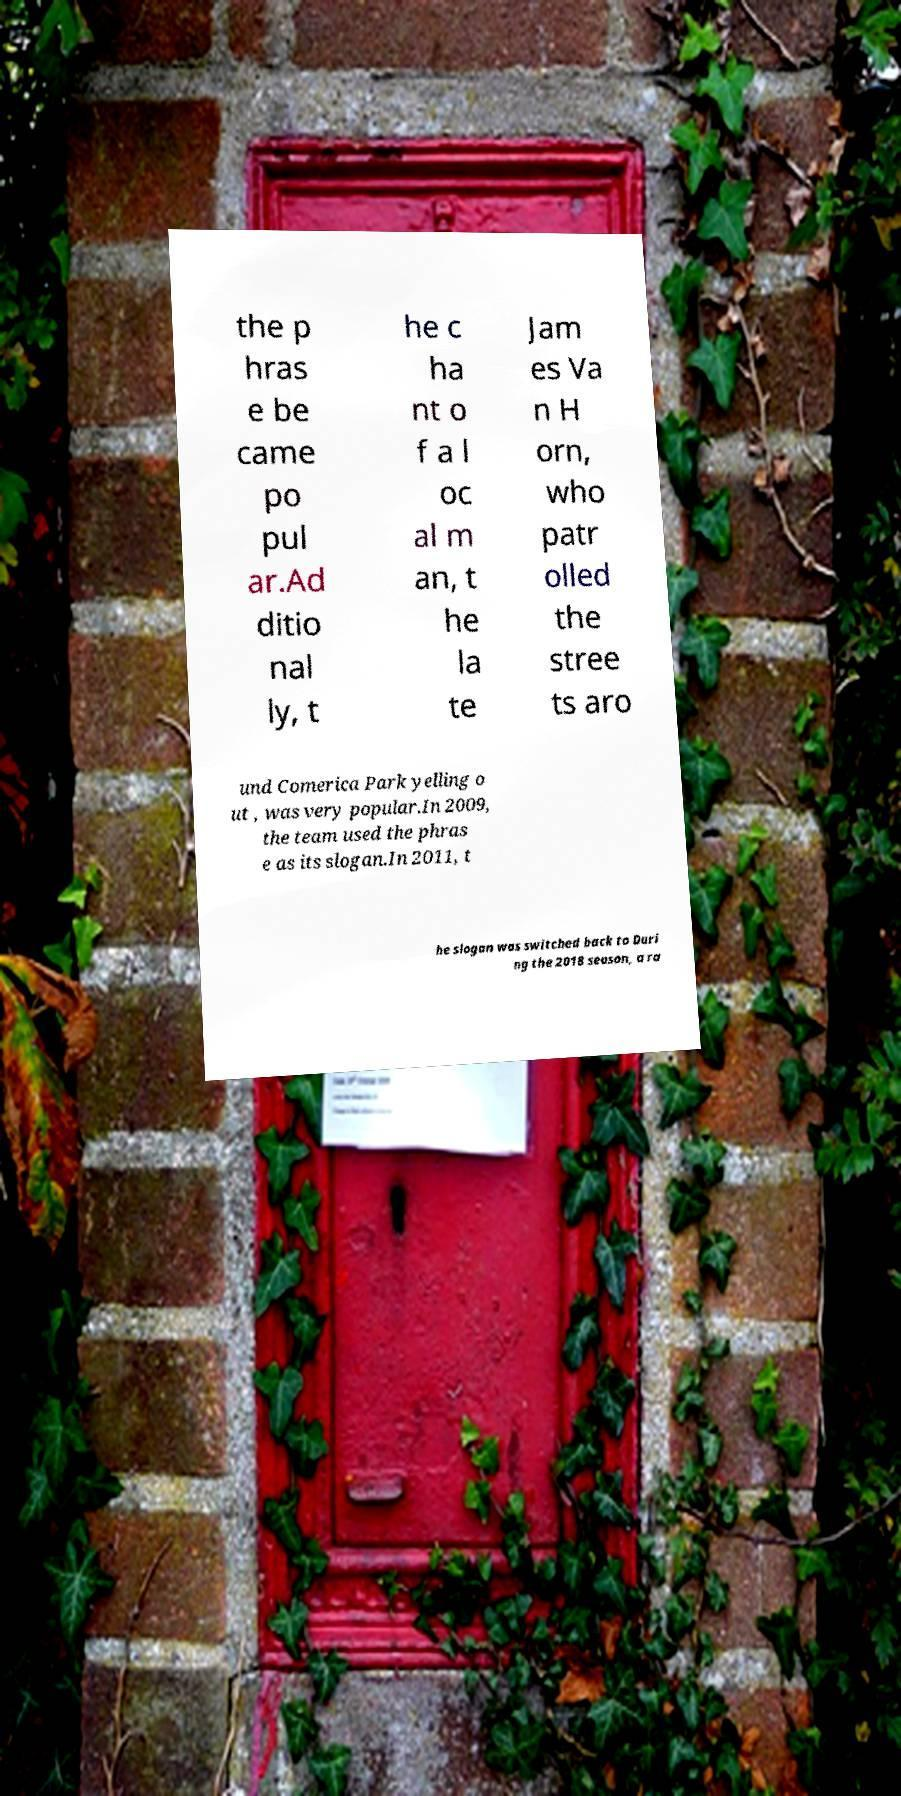There's text embedded in this image that I need extracted. Can you transcribe it verbatim? the p hras e be came po pul ar.Ad ditio nal ly, t he c ha nt o f a l oc al m an, t he la te Jam es Va n H orn, who patr olled the stree ts aro und Comerica Park yelling o ut , was very popular.In 2009, the team used the phras e as its slogan.In 2011, t he slogan was switched back to Duri ng the 2018 season, a ra 